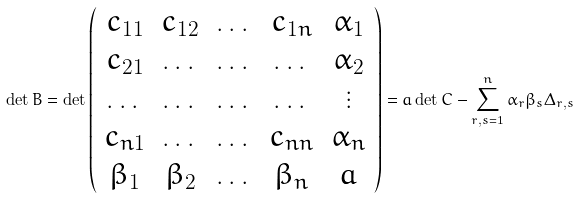<formula> <loc_0><loc_0><loc_500><loc_500>\det B = \det \left ( \begin{array} { c c c c c } c _ { 1 1 } & c _ { 1 2 } & \dots & c _ { 1 n } & \alpha _ { 1 } \\ c _ { 2 1 } & \dots & \dots & \dots & \alpha _ { 2 } \\ \dots & \dots & \dots & \dots & \vdots \\ c _ { n 1 } & \dots & \dots & c _ { n n } & \alpha _ { n } \\ \beta _ { 1 } & \beta _ { 2 } & \dots & \beta _ { n } & a \\ \end{array} \right ) = a \det C - \sum _ { r , s = 1 } ^ { n } \alpha _ { r } \beta _ { s } \Delta _ { r , s }</formula> 